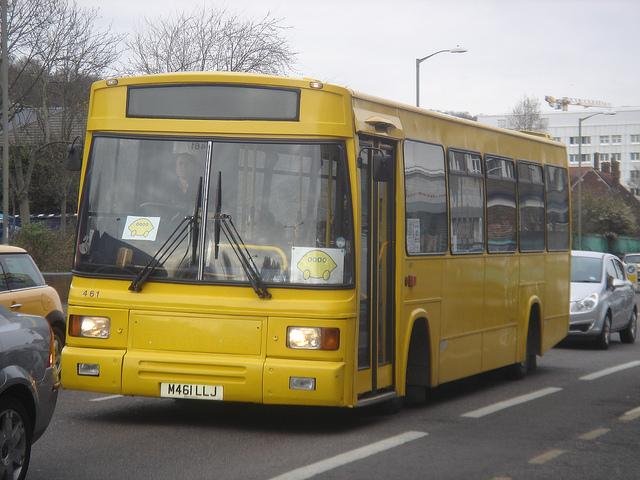What does the license plate read?
Quick response, please. N46illj. How many buses are on the road?
Short answer required. 1. Why is the symbol in the bus window a lemon?
Short answer required. To identify it. 